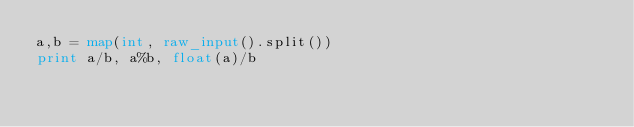Convert code to text. <code><loc_0><loc_0><loc_500><loc_500><_Python_>a,b = map(int, raw_input().split())
print a/b, a%b, float(a)/b</code> 